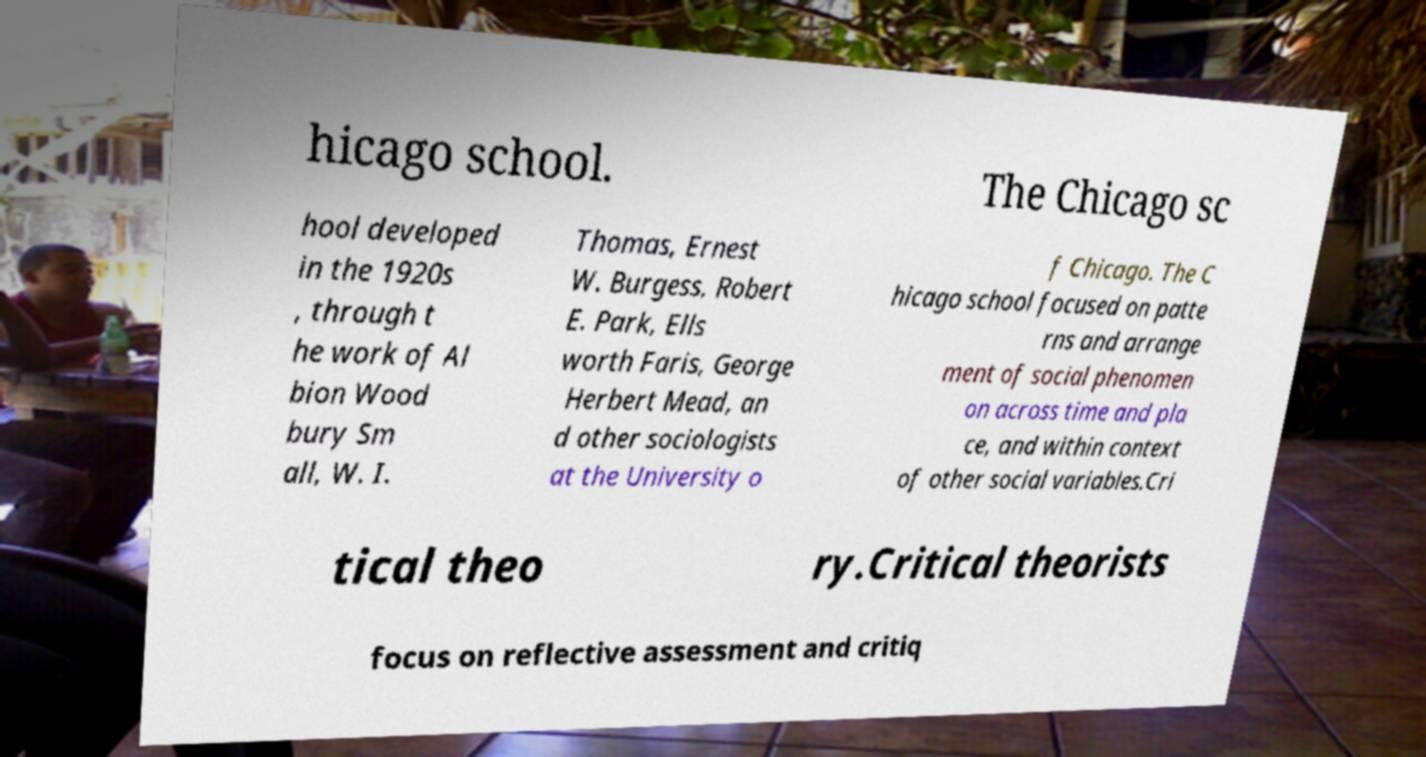For documentation purposes, I need the text within this image transcribed. Could you provide that? hicago school. The Chicago sc hool developed in the 1920s , through t he work of Al bion Wood bury Sm all, W. I. Thomas, Ernest W. Burgess, Robert E. Park, Ells worth Faris, George Herbert Mead, an d other sociologists at the University o f Chicago. The C hicago school focused on patte rns and arrange ment of social phenomen on across time and pla ce, and within context of other social variables.Cri tical theo ry.Critical theorists focus on reflective assessment and critiq 